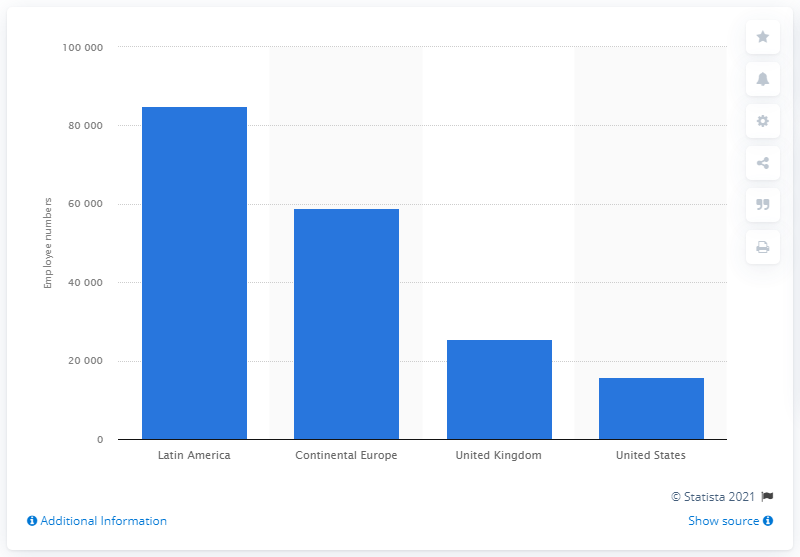Point out several critical features in this image. In 2014, Banco Santander had a total of 58,878 employees working in its offices located in continental Europe. In 2014, Banco Santander had approximately 85,009 people working in Latin America. 